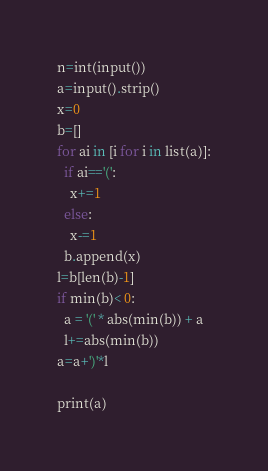<code> <loc_0><loc_0><loc_500><loc_500><_Python_>n=int(input())
a=input().strip()
x=0
b=[]
for ai in [i for i in list(a)]:
  if ai=='(':
    x+=1
  else:
    x-=1
  b.append(x)
l=b[len(b)-1]	
if min(b)< 0:
  a = '(' * abs(min(b)) + a
  l+=abs(min(b))
a=a+')'*l
    
print(a)</code> 